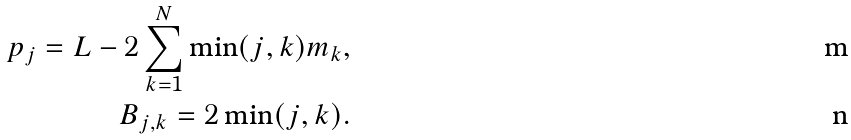<formula> <loc_0><loc_0><loc_500><loc_500>p _ { j } = L - 2 \sum _ { k = 1 } ^ { N } \min ( j , k ) m _ { k } , \\ B _ { j , k } = 2 \min ( j , k ) .</formula> 